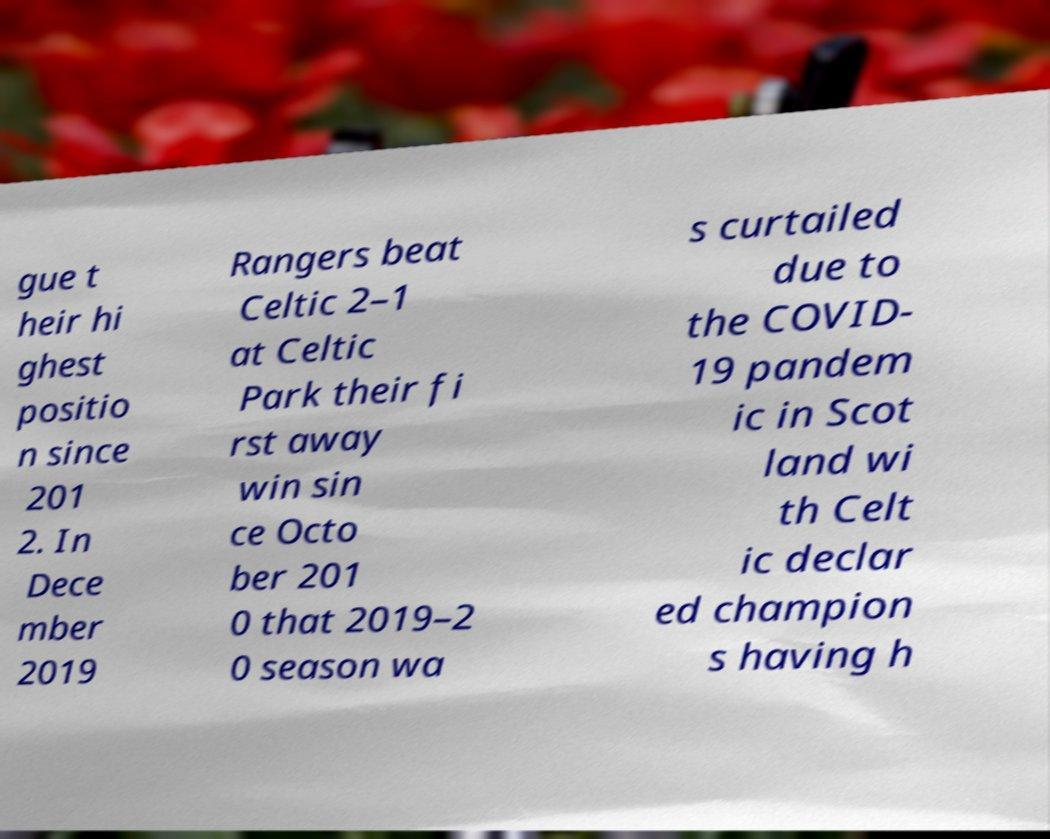I need the written content from this picture converted into text. Can you do that? gue t heir hi ghest positio n since 201 2. In Dece mber 2019 Rangers beat Celtic 2–1 at Celtic Park their fi rst away win sin ce Octo ber 201 0 that 2019–2 0 season wa s curtailed due to the COVID- 19 pandem ic in Scot land wi th Celt ic declar ed champion s having h 